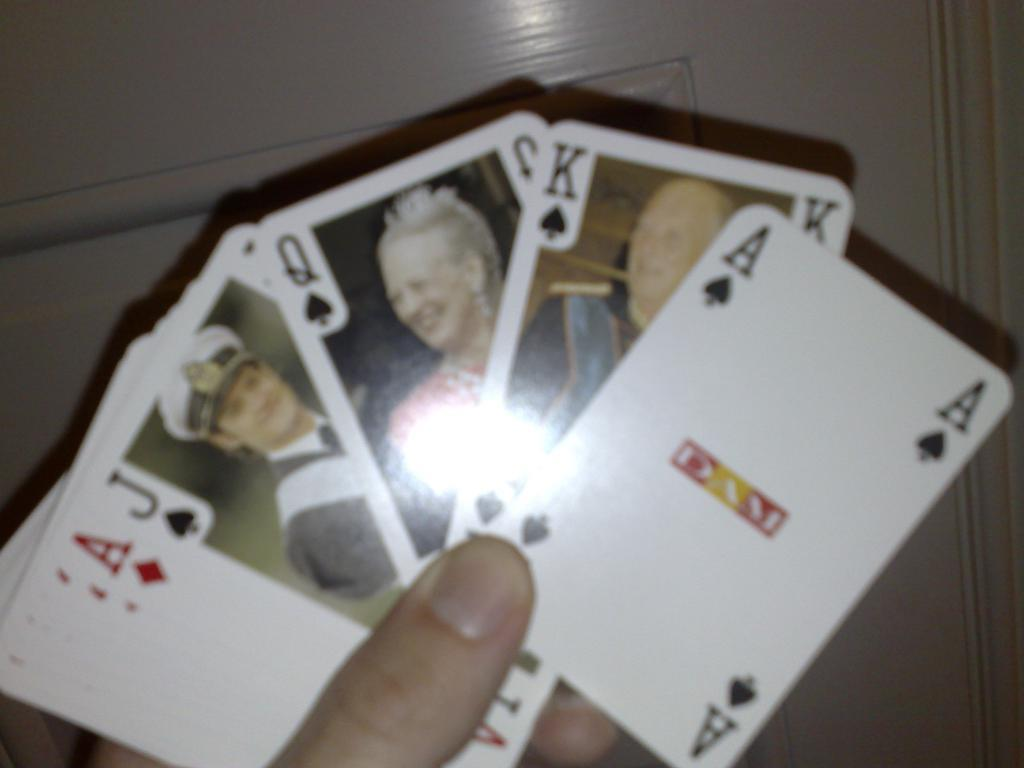What can be seen in the image? There is a person's hand in the image. What is the hand holding? The hand is holding cards. What type of powder is visible on the cards in the image? There is no powder visible on the cards in the image; only the hand and cards are present. 